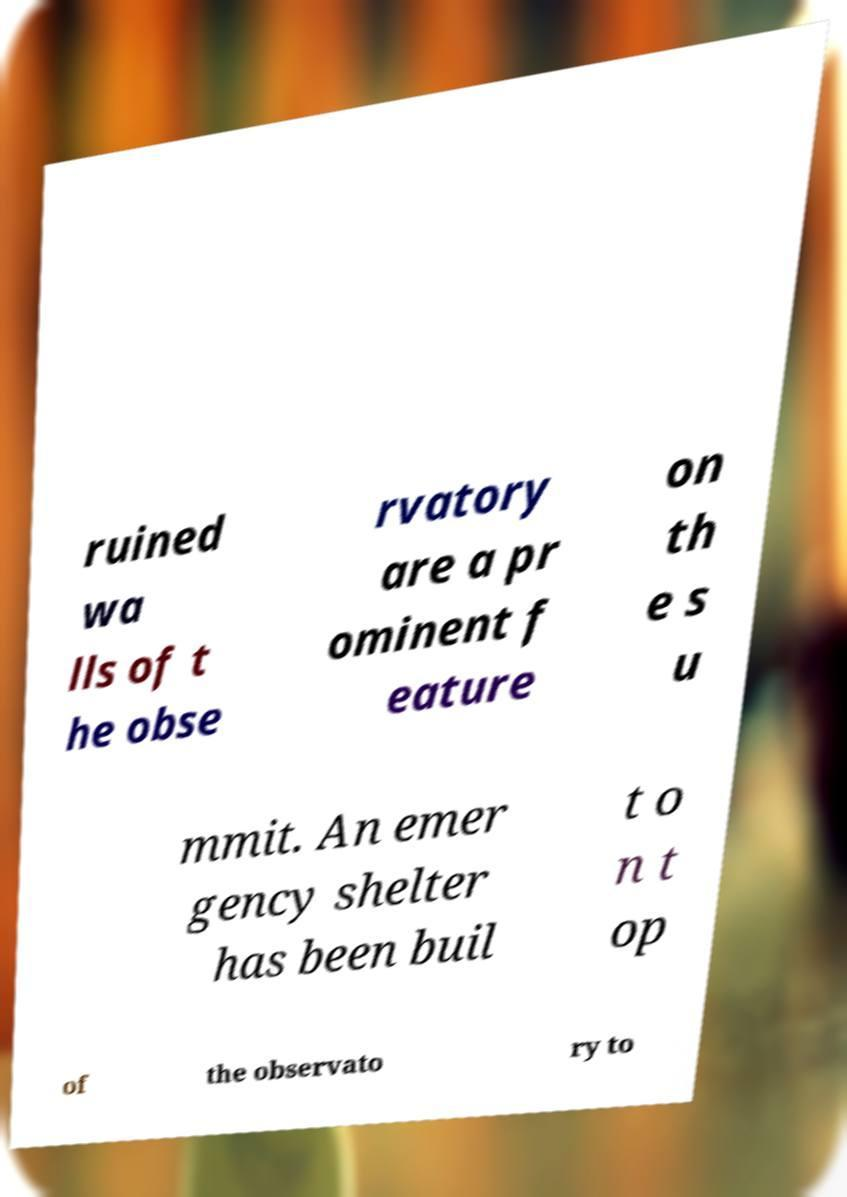Please identify and transcribe the text found in this image. ruined wa lls of t he obse rvatory are a pr ominent f eature on th e s u mmit. An emer gency shelter has been buil t o n t op of the observato ry to 